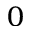Convert formula to latex. <formula><loc_0><loc_0><loc_500><loc_500>_ { 0 }</formula> 